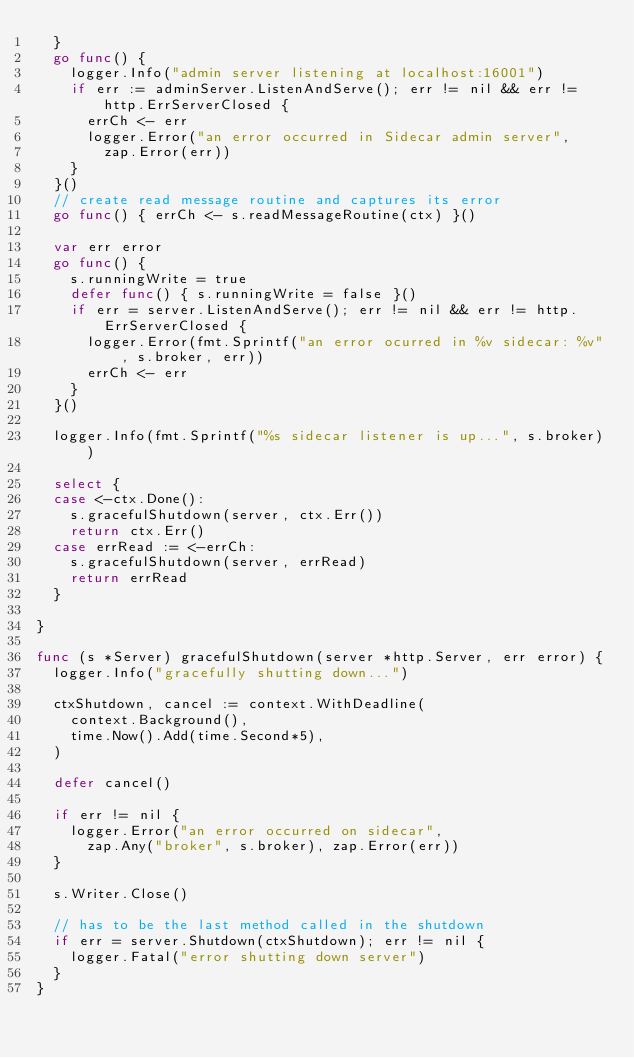Convert code to text. <code><loc_0><loc_0><loc_500><loc_500><_Go_>	}
	go func() {
		logger.Info("admin server listening at localhost:16001")
		if err := adminServer.ListenAndServe(); err != nil && err != http.ErrServerClosed {
			errCh <- err
			logger.Error("an error occurred in Sidecar admin server",
				zap.Error(err))
		}
	}()
	// create read message routine and captures its error
	go func() { errCh <- s.readMessageRoutine(ctx) }()

	var err error
	go func() {
		s.runningWrite = true
		defer func() { s.runningWrite = false }()
		if err = server.ListenAndServe(); err != nil && err != http.ErrServerClosed {
			logger.Error(fmt.Sprintf("an error ocurred in %v sidecar: %v", s.broker, err))
			errCh <- err
		}
	}()

	logger.Info(fmt.Sprintf("%s sidecar listener is up...", s.broker))

	select {
	case <-ctx.Done():
		s.gracefulShutdown(server, ctx.Err())
		return ctx.Err()
	case errRead := <-errCh:
		s.gracefulShutdown(server, errRead)
		return errRead
	}

}

func (s *Server) gracefulShutdown(server *http.Server, err error) {
	logger.Info("gracefully shutting down...")

	ctxShutdown, cancel := context.WithDeadline(
		context.Background(),
		time.Now().Add(time.Second*5),
	)

	defer cancel()

	if err != nil {
		logger.Error("an error occurred on sidecar",
			zap.Any("broker", s.broker), zap.Error(err))
	}

	s.Writer.Close()

	// has to be the last method called in the shutdown
	if err = server.Shutdown(ctxShutdown); err != nil {
		logger.Fatal("error shutting down server")
	}
}
</code> 